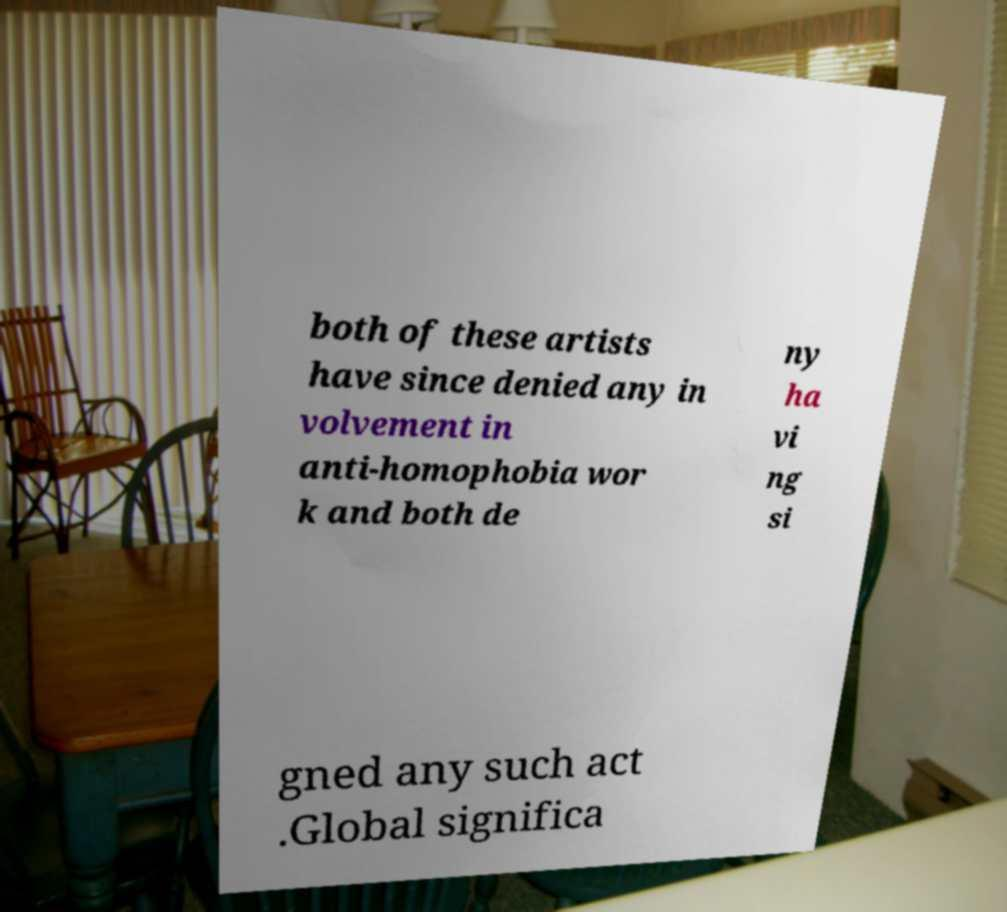For documentation purposes, I need the text within this image transcribed. Could you provide that? both of these artists have since denied any in volvement in anti-homophobia wor k and both de ny ha vi ng si gned any such act .Global significa 